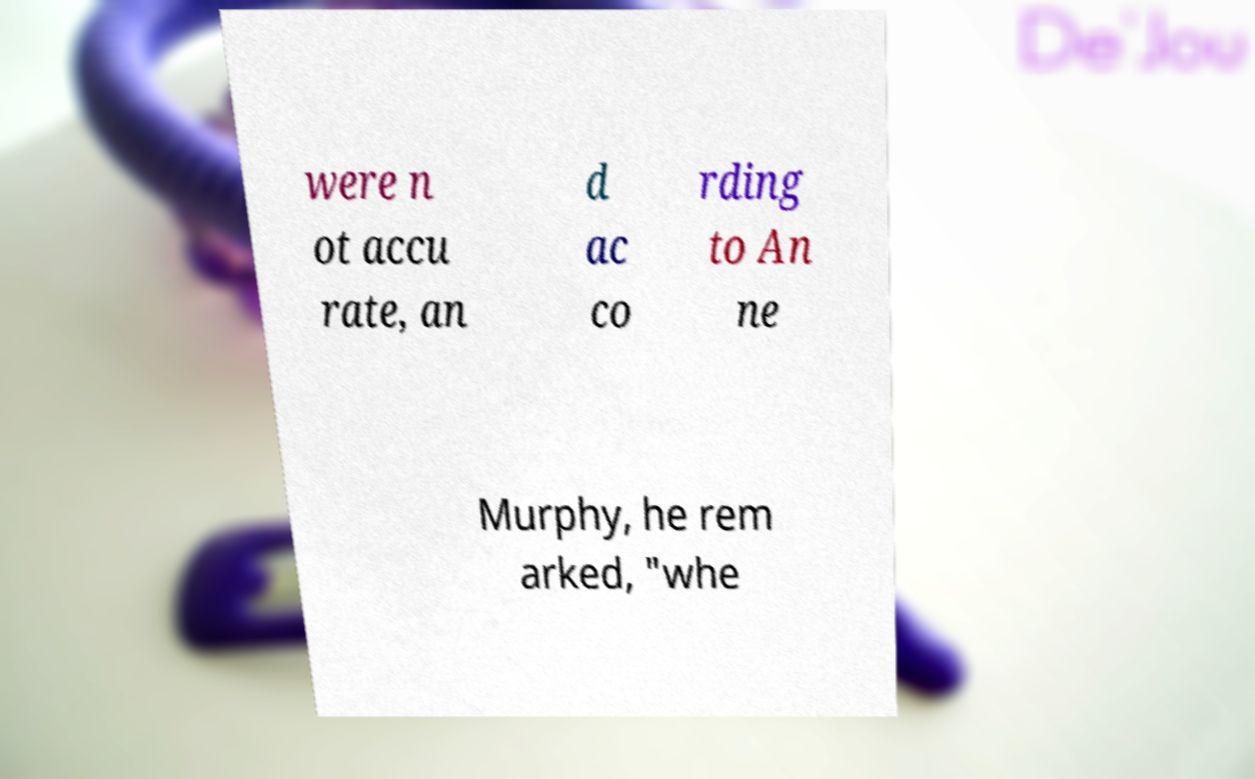There's text embedded in this image that I need extracted. Can you transcribe it verbatim? were n ot accu rate, an d ac co rding to An ne Murphy, he rem arked, "whe 